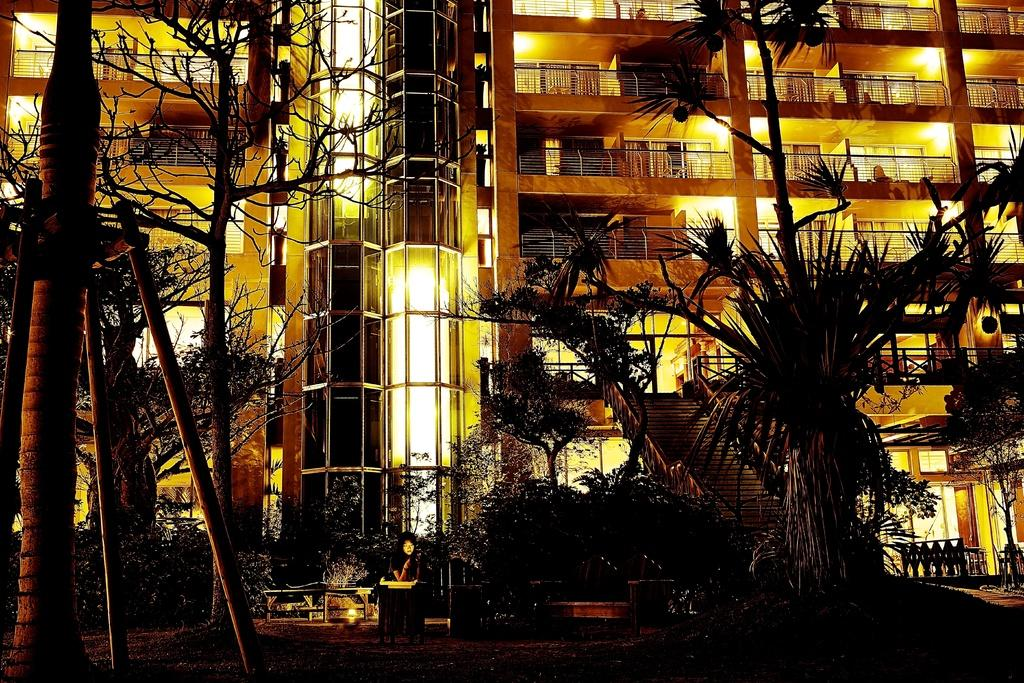What type of natural elements can be seen in the image? There are many trees in the image. What man-made structures are present in the image? There are poles and a building with railings and lights in the background of the image. Can you describe the lady in the image? There is a lady in the image, but no specific details about her appearance are provided. What type of seating is available in the image? There are benches in the image. What type of edge can be seen on the lady's dress in the image? There is no information provided about the lady's dress, so we cannot determine the type of edge on it. Is there any sleet visible in the image? There is no mention of sleet in the provided facts, so we cannot determine if it is present in the image. 